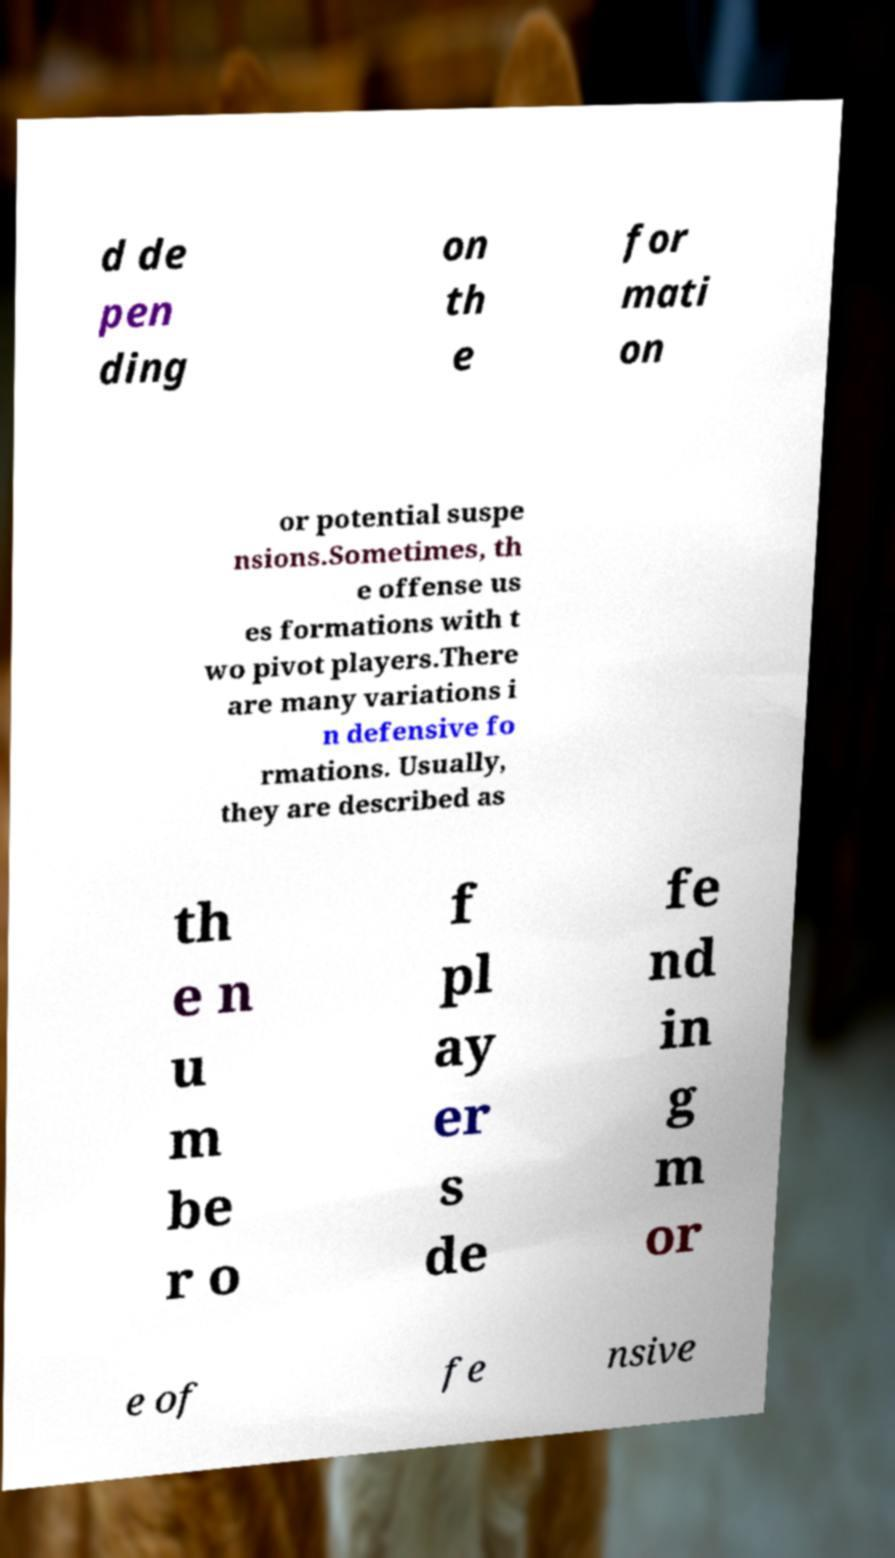Could you assist in decoding the text presented in this image and type it out clearly? d de pen ding on th e for mati on or potential suspe nsions.Sometimes, th e offense us es formations with t wo pivot players.There are many variations i n defensive fo rmations. Usually, they are described as th e n u m be r o f pl ay er s de fe nd in g m or e of fe nsive 